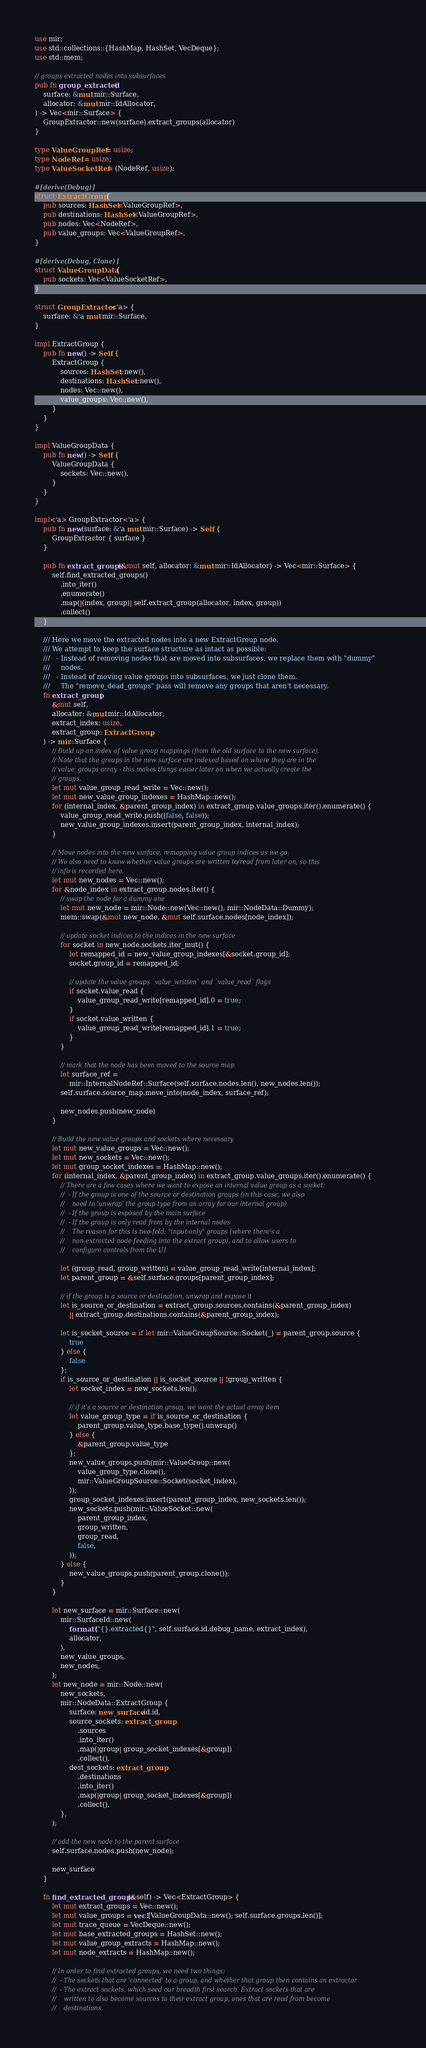<code> <loc_0><loc_0><loc_500><loc_500><_Rust_>use mir;
use std::collections::{HashMap, HashSet, VecDeque};
use std::mem;

// groups extracted nodes into subsurfaces
pub fn group_extracted(
    surface: &mut mir::Surface,
    allocator: &mut mir::IdAllocator,
) -> Vec<mir::Surface> {
    GroupExtractor::new(surface).extract_groups(allocator)
}

type ValueGroupRef = usize;
type NodeRef = usize;
type ValueSocketRef = (NodeRef, usize);

#[derive(Debug)]
struct ExtractGroup {
    pub sources: HashSet<ValueGroupRef>,
    pub destinations: HashSet<ValueGroupRef>,
    pub nodes: Vec<NodeRef>,
    pub value_groups: Vec<ValueGroupRef>,
}

#[derive(Debug, Clone)]
struct ValueGroupData {
    pub sockets: Vec<ValueSocketRef>,
}

struct GroupExtractor<'a> {
    surface: &'a mut mir::Surface,
}

impl ExtractGroup {
    pub fn new() -> Self {
        ExtractGroup {
            sources: HashSet::new(),
            destinations: HashSet::new(),
            nodes: Vec::new(),
            value_groups: Vec::new(),
        }
    }
}

impl ValueGroupData {
    pub fn new() -> Self {
        ValueGroupData {
            sockets: Vec::new(),
        }
    }
}

impl<'a> GroupExtractor<'a> {
    pub fn new(surface: &'a mut mir::Surface) -> Self {
        GroupExtractor { surface }
    }

    pub fn extract_groups(&mut self, allocator: &mut mir::IdAllocator) -> Vec<mir::Surface> {
        self.find_extracted_groups()
            .into_iter()
            .enumerate()
            .map(|(index, group)| self.extract_group(allocator, index, group))
            .collect()
    }

    /// Here we move the extracted nodes into a new ExtractGroup node.
    /// We attempt to keep the surface structure as intact as possible:
    ///   - Instead of removing nodes that are moved into subsurfaces, we replace them with "dummy"
    ///     nodes.
    ///   - Instead of moving value groups into subsurfaces, we just clone them.
    ///     The "remove_dead_groups" pass will remove any groups that aren't necessary.
    fn extract_group(
        &mut self,
        allocator: &mut mir::IdAllocator,
        extract_index: usize,
        extract_group: ExtractGroup,
    ) -> mir::Surface {
        // Build up an index of value group mappings (from the old surface to the new surface).
        // Note that the groups in the new surface are indexed based on where they are in the
        // value_groups array - this makes things easier later on when we actually create the
        // groups.
        let mut value_group_read_write = Vec::new();
        let mut new_value_group_indexes = HashMap::new();
        for (internal_index, &parent_group_index) in extract_group.value_groups.iter().enumerate() {
            value_group_read_write.push((false, false));
            new_value_group_indexes.insert(parent_group_index, internal_index);
        }

        // Move nodes into the new surface, remapping value group indices as we go.
        // We also need to know whether value groups are written to/read from later on, so this
        // info is recorded here.
        let mut new_nodes = Vec::new();
        for &node_index in extract_group.nodes.iter() {
            // swap the node for a dummy one
            let mut new_node = mir::Node::new(Vec::new(), mir::NodeData::Dummy);
            mem::swap(&mut new_node, &mut self.surface.nodes[node_index]);

            // update socket indices to the indices in the new surface
            for socket in new_node.sockets.iter_mut() {
                let remapped_id = new_value_group_indexes[&socket.group_id];
                socket.group_id = remapped_id;

                // update the value groups `value_written` and `value_read` flags
                if socket.value_read {
                    value_group_read_write[remapped_id].0 = true;
                }
                if socket.value_written {
                    value_group_read_write[remapped_id].1 = true;
                }
            }

            // mark that the node has been moved to the source map
            let surface_ref =
                mir::InternalNodeRef::Surface(self.surface.nodes.len(), new_nodes.len());
            self.surface.source_map.move_into(node_index, surface_ref);

            new_nodes.push(new_node)
        }

        // Build the new value groups and sockets where necessary
        let mut new_value_groups = Vec::new();
        let mut new_sockets = Vec::new();
        let mut group_socket_indexes = HashMap::new();
        for (internal_index, &parent_group_index) in extract_group.value_groups.iter().enumerate() {
            // There are a few cases where we want to expose an internal value group as a socket:
            //  - If the group is one of the source or destination groups (in this case, we also
            //    need to 'unwrap' the group type from an array for our internal group)
            //  - If the group is exposed by the main surface
            //  - If the group is only read from by the internal nodes
            //    The reason for this is two-fold: "input-only" groups (where there's a
            //    non-extracted node feeding into the extract group), and to allow users to
            //    configure controls from the UI

            let (group_read, group_written) = value_group_read_write[internal_index];
            let parent_group = &self.surface.groups[parent_group_index];

            // if the group is a source or destination, unwrap and expose it
            let is_source_or_destination = extract_group.sources.contains(&parent_group_index)
                || extract_group.destinations.contains(&parent_group_index);

            let is_socket_source = if let mir::ValueGroupSource::Socket(_) = parent_group.source {
                true
            } else {
                false
            };
            if is_source_or_destination || is_socket_source || !group_written {
                let socket_index = new_sockets.len();

                // if it's a source or destination group, we want the actual array item
                let value_group_type = if is_source_or_destination {
                    parent_group.value_type.base_type().unwrap()
                } else {
                    &parent_group.value_type
                };
                new_value_groups.push(mir::ValueGroup::new(
                    value_group_type.clone(),
                    mir::ValueGroupSource::Socket(socket_index),
                ));
                group_socket_indexes.insert(parent_group_index, new_sockets.len());
                new_sockets.push(mir::ValueSocket::new(
                    parent_group_index,
                    group_written,
                    group_read,
                    false,
                ));
            } else {
                new_value_groups.push(parent_group.clone());
            }
        }

        let new_surface = mir::Surface::new(
            mir::SurfaceId::new(
                format!("{}.extracted{}", self.surface.id.debug_name, extract_index),
                allocator,
            ),
            new_value_groups,
            new_nodes,
        );
        let new_node = mir::Node::new(
            new_sockets,
            mir::NodeData::ExtractGroup {
                surface: new_surface.id.id,
                source_sockets: extract_group
                    .sources
                    .into_iter()
                    .map(|group| group_socket_indexes[&group])
                    .collect(),
                dest_sockets: extract_group
                    .destinations
                    .into_iter()
                    .map(|group| group_socket_indexes[&group])
                    .collect(),
            },
        );

        // add the new node to the parent surface
        self.surface.nodes.push(new_node);

        new_surface
    }

    fn find_extracted_groups(&self) -> Vec<ExtractGroup> {
        let mut extract_groups = Vec::new();
        let mut value_groups = vec![ValueGroupData::new(); self.surface.groups.len()];
        let mut trace_queue = VecDeque::new();
        let mut base_extracted_groups = HashSet::new();
        let mut value_group_extracts = HashMap::new();
        let mut node_extracts = HashMap::new();

        // In order to find extracted groups, we need two things:
        //  - The sockets that are 'connected' to a group, and whether that group then contains an extractor
        //  - The extract sockets, which seed our breadth first search. Extract sockets that are
        //    written to also become sources to their extract group, ones that are read from become
        //    destinations.</code> 